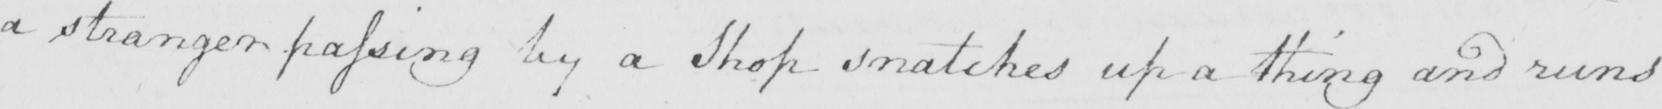Can you tell me what this handwritten text says? a stranger passing by a Shop snatches up a thing and runs 